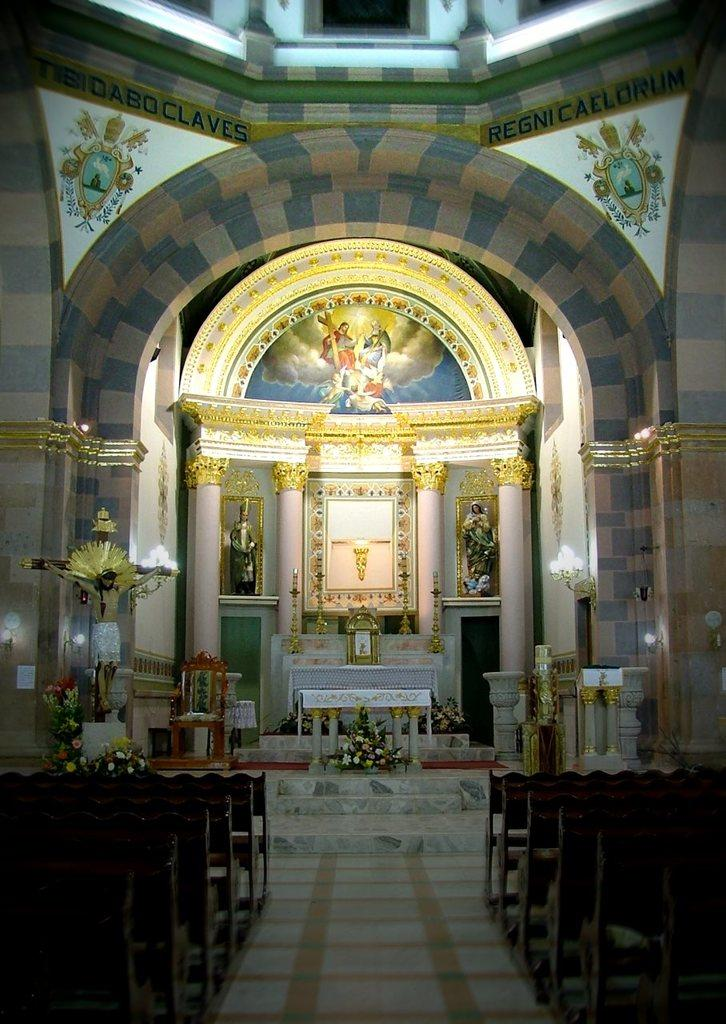What is the main structure in the center of the image? There is a wall in the center of the image. What architectural elements can be seen in the image? There are pillars in the image. What decorative elements are present in the image? There are statues, lights, bouquets, and benches in the image. What other objects can be seen in the image? There are other objects in the image. What design elements are present on the wall? There are designs on the wall. What text is present on the wall? There is text on the wall. What type of coil is wrapped around the statues in the image? There is no coil present in the image; the statues are not wrapped in any coil. How many balloons are tied to the bouquets in the image? There are no balloons present in the image; only bouquets are mentioned. 